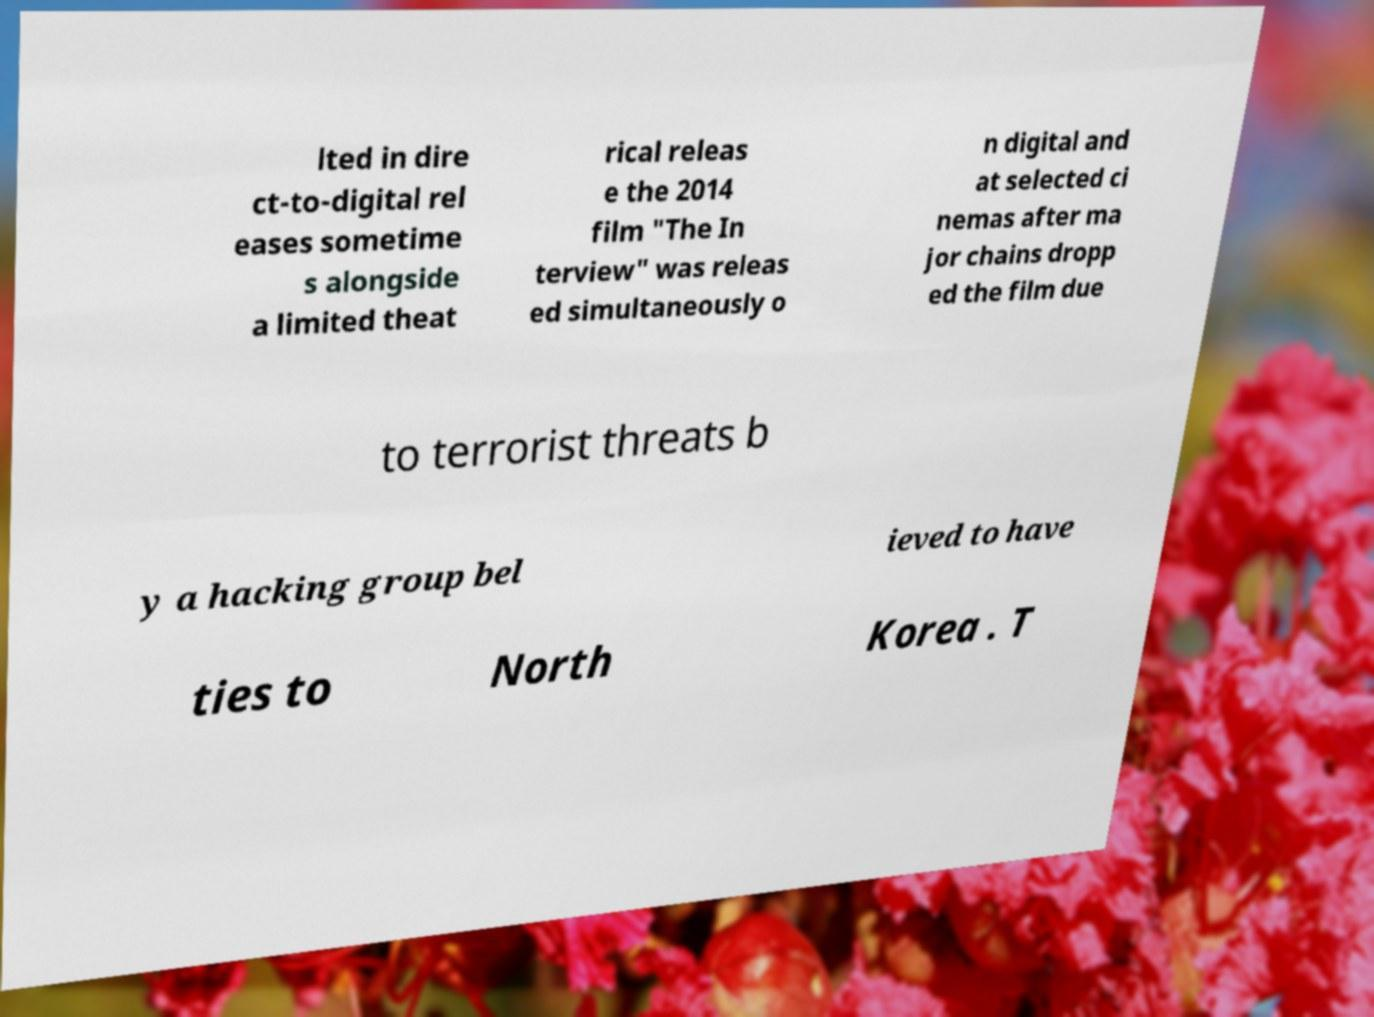Can you read and provide the text displayed in the image?This photo seems to have some interesting text. Can you extract and type it out for me? lted in dire ct-to-digital rel eases sometime s alongside a limited theat rical releas e the 2014 film "The In terview" was releas ed simultaneously o n digital and at selected ci nemas after ma jor chains dropp ed the film due to terrorist threats b y a hacking group bel ieved to have ties to North Korea . T 